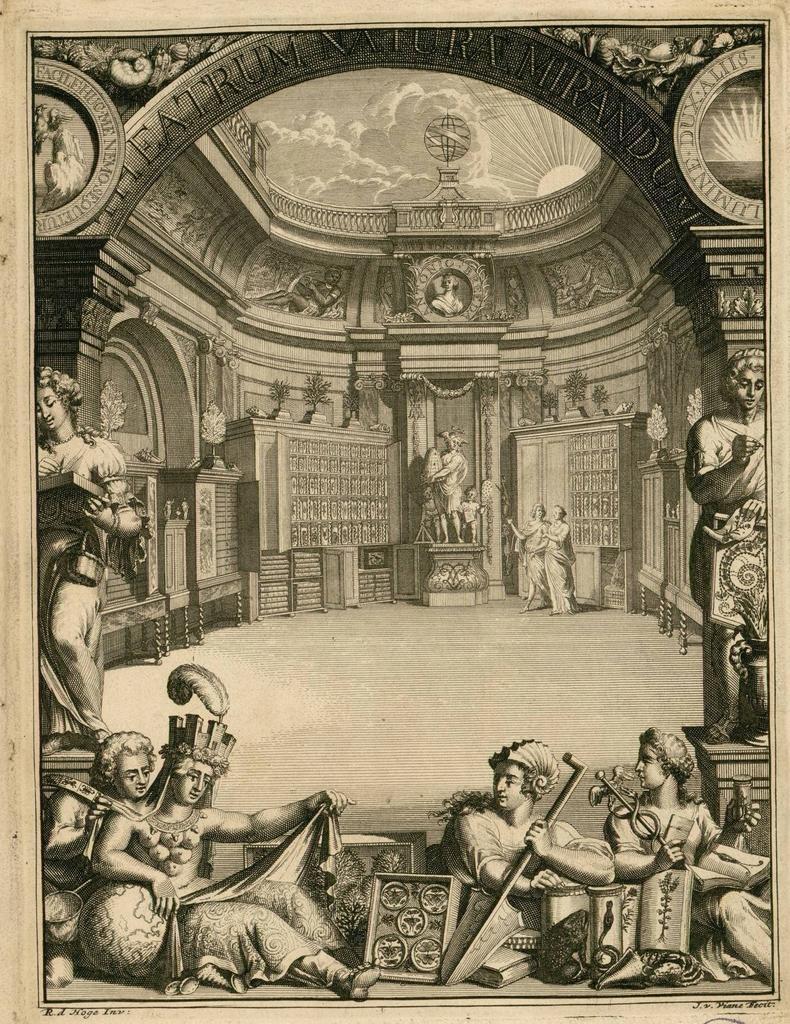Could you give a brief overview of what you see in this image? This picture is very old. In this picture there is an entrance with arch. On the arch there is some text at the top and there are statues at the bottom. Inside the arch there are statues to the wall. 